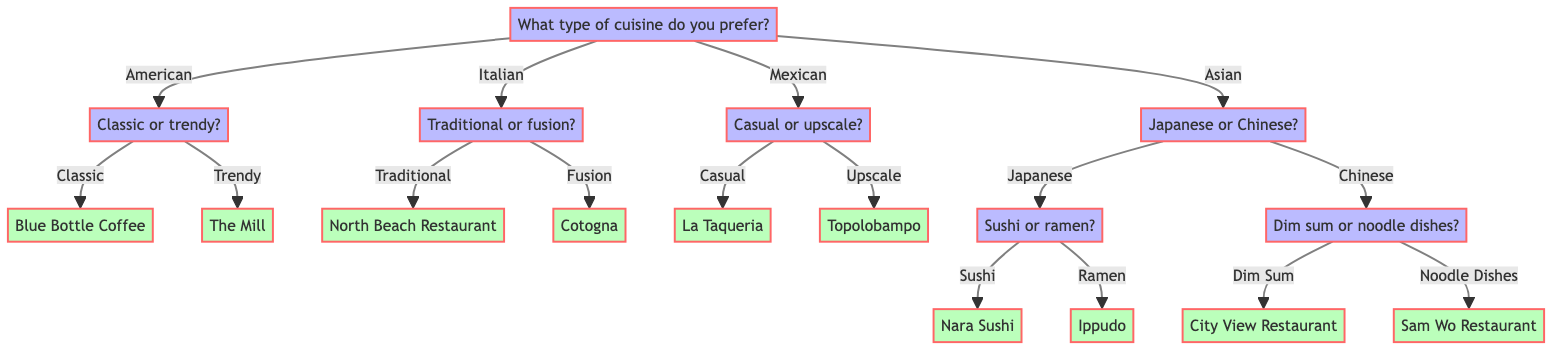What type of cuisine can I choose from? The top node "What type of cuisine do you prefer?" has options branching out, which lists the available cuisines: American, Italian, Mexican, and Asian.
Answer: American, Italian, Mexican, Asian How many recommendations are there for American cuisine? The "American" node branches into two options—Classic and Trendy—each leading to one recommendation, totaling two recommendations for American cuisine.
Answer: 2 What is the recommendation for casual Mexican dining? The Mexican branch leads to a question about the dining experience—casual or upscale. Choosing "Casual" directs to the recommendation "La Taqueria" as the dining option for that preference.
Answer: La Taqueria If I choose Asian cuisine, which two sub-options do I have? The Asian node splits into two preferences between Japanese and Chinese cuisines, providing specific branches for each type for further questioning.
Answer: Japanese, Chinese What is the recommendation for traditional Italian cuisine? From the Italian node, choosing "Traditional" leads to a single recommendation of "North Beach Restaurant."
Answer: North Beach Restaurant If I prefer sushi in the Asian category, what will my final recommendation be? Within the Asian branch, selecting Japanese leads to a question about sushi or ramen. Choosing "Sushi" results in the recommendation to "Nara Sushi."
Answer: Nara Sushi What type of dining experience can I choose for Mexican cuisine other than casual? The Mexican cuisine node offers two dining experience types: casual and upscale. Choosing the non-casual option indicates the upscale dining experience, which is "Topolobampo."
Answer: Upscale How many cuisine types lead to a recommendation of a restaurant? Every cuisine type (American, Italian, Mexican, and Asian) presented in the diagram leads to specific recommendations, so there are a total of four types, each with at least one restaurant as an option.
Answer: 4 What do I need to decide after selecting Asian cuisine? After selecting Asian cuisine, the next step is deciding between Japanese or Chinese cuisine, which leads to further specific questions regarding sushi or ramen, and dim sum or noodle dishes, respectively.
Answer: Japanese or Chinese 